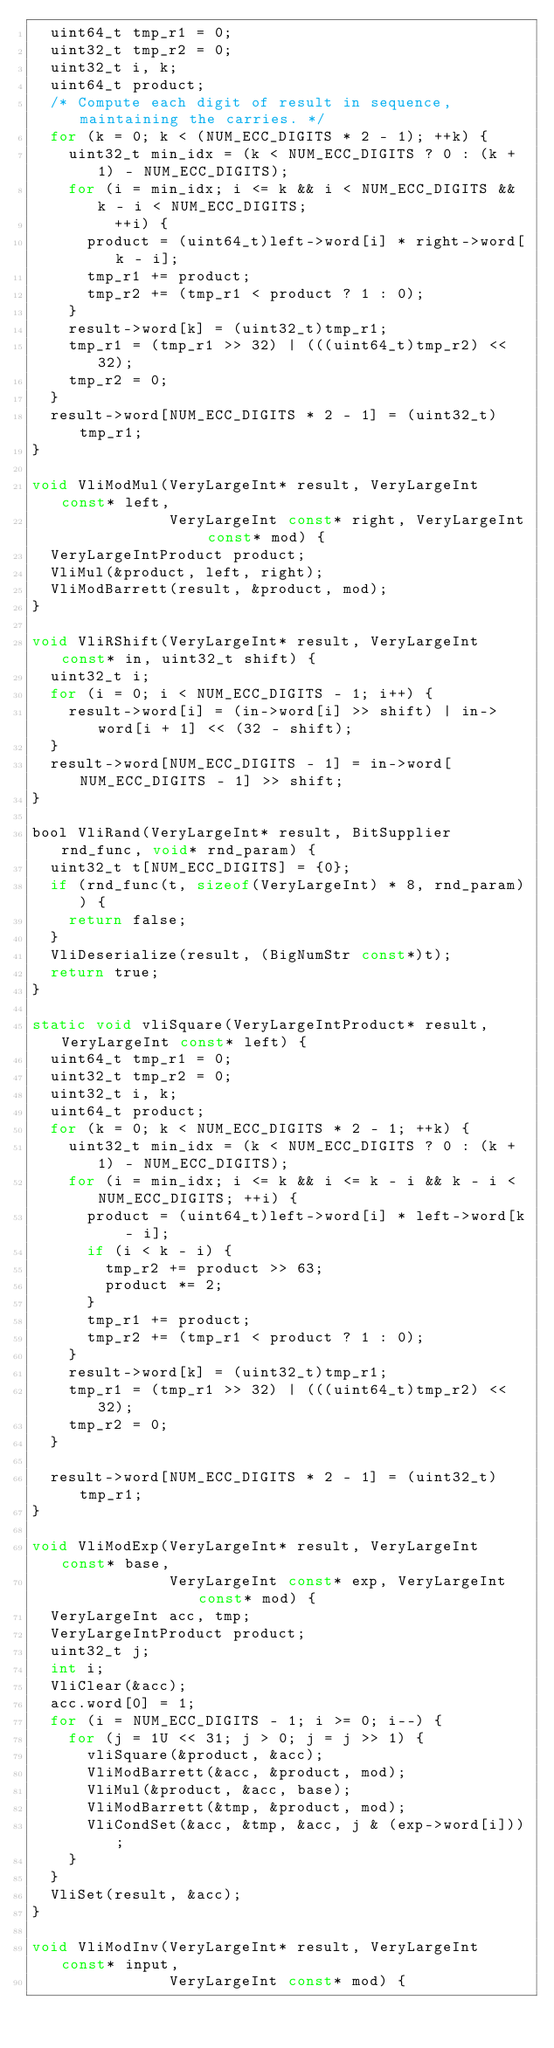<code> <loc_0><loc_0><loc_500><loc_500><_C_>  uint64_t tmp_r1 = 0;
  uint32_t tmp_r2 = 0;
  uint32_t i, k;
  uint64_t product;
  /* Compute each digit of result in sequence, maintaining the carries. */
  for (k = 0; k < (NUM_ECC_DIGITS * 2 - 1); ++k) {
    uint32_t min_idx = (k < NUM_ECC_DIGITS ? 0 : (k + 1) - NUM_ECC_DIGITS);
    for (i = min_idx; i <= k && i < NUM_ECC_DIGITS && k - i < NUM_ECC_DIGITS;
         ++i) {
      product = (uint64_t)left->word[i] * right->word[k - i];
      tmp_r1 += product;
      tmp_r2 += (tmp_r1 < product ? 1 : 0);
    }
    result->word[k] = (uint32_t)tmp_r1;
    tmp_r1 = (tmp_r1 >> 32) | (((uint64_t)tmp_r2) << 32);
    tmp_r2 = 0;
  }
  result->word[NUM_ECC_DIGITS * 2 - 1] = (uint32_t)tmp_r1;
}

void VliModMul(VeryLargeInt* result, VeryLargeInt const* left,
               VeryLargeInt const* right, VeryLargeInt const* mod) {
  VeryLargeIntProduct product;
  VliMul(&product, left, right);
  VliModBarrett(result, &product, mod);
}

void VliRShift(VeryLargeInt* result, VeryLargeInt const* in, uint32_t shift) {
  uint32_t i;
  for (i = 0; i < NUM_ECC_DIGITS - 1; i++) {
    result->word[i] = (in->word[i] >> shift) | in->word[i + 1] << (32 - shift);
  }
  result->word[NUM_ECC_DIGITS - 1] = in->word[NUM_ECC_DIGITS - 1] >> shift;
}

bool VliRand(VeryLargeInt* result, BitSupplier rnd_func, void* rnd_param) {
  uint32_t t[NUM_ECC_DIGITS] = {0};
  if (rnd_func(t, sizeof(VeryLargeInt) * 8, rnd_param)) {
    return false;
  }
  VliDeserialize(result, (BigNumStr const*)t);
  return true;
}

static void vliSquare(VeryLargeIntProduct* result, VeryLargeInt const* left) {
  uint64_t tmp_r1 = 0;
  uint32_t tmp_r2 = 0;
  uint32_t i, k;
  uint64_t product;
  for (k = 0; k < NUM_ECC_DIGITS * 2 - 1; ++k) {
    uint32_t min_idx = (k < NUM_ECC_DIGITS ? 0 : (k + 1) - NUM_ECC_DIGITS);
    for (i = min_idx; i <= k && i <= k - i && k - i < NUM_ECC_DIGITS; ++i) {
      product = (uint64_t)left->word[i] * left->word[k - i];
      if (i < k - i) {
        tmp_r2 += product >> 63;
        product *= 2;
      }
      tmp_r1 += product;
      tmp_r2 += (tmp_r1 < product ? 1 : 0);
    }
    result->word[k] = (uint32_t)tmp_r1;
    tmp_r1 = (tmp_r1 >> 32) | (((uint64_t)tmp_r2) << 32);
    tmp_r2 = 0;
  }

  result->word[NUM_ECC_DIGITS * 2 - 1] = (uint32_t)tmp_r1;
}

void VliModExp(VeryLargeInt* result, VeryLargeInt const* base,
               VeryLargeInt const* exp, VeryLargeInt const* mod) {
  VeryLargeInt acc, tmp;
  VeryLargeIntProduct product;
  uint32_t j;
  int i;
  VliClear(&acc);
  acc.word[0] = 1;
  for (i = NUM_ECC_DIGITS - 1; i >= 0; i--) {
    for (j = 1U << 31; j > 0; j = j >> 1) {
      vliSquare(&product, &acc);
      VliModBarrett(&acc, &product, mod);
      VliMul(&product, &acc, base);
      VliModBarrett(&tmp, &product, mod);
      VliCondSet(&acc, &tmp, &acc, j & (exp->word[i]));
    }
  }
  VliSet(result, &acc);
}

void VliModInv(VeryLargeInt* result, VeryLargeInt const* input,
               VeryLargeInt const* mod) {</code> 